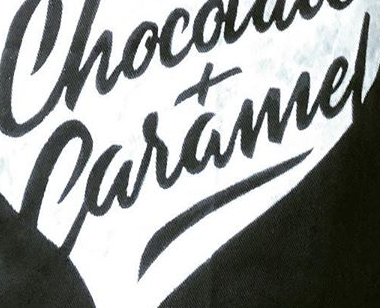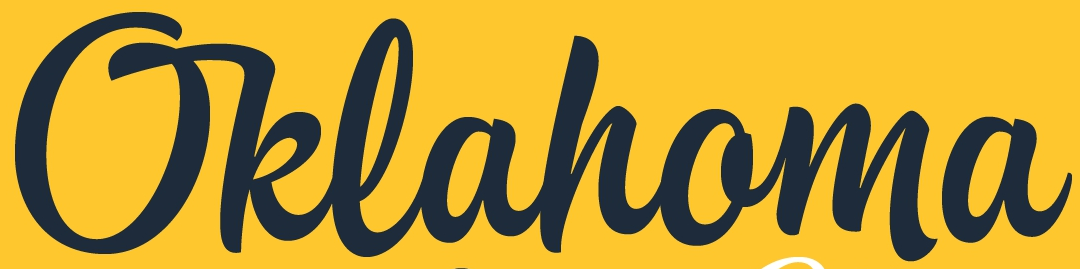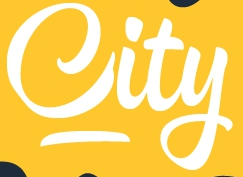Read the text content from these images in order, separated by a semicolon. Caramel; Oklahoma; City 